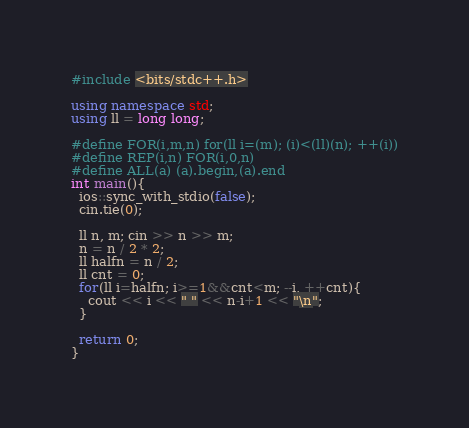Convert code to text. <code><loc_0><loc_0><loc_500><loc_500><_C++_>#include <bits/stdc++.h>

using namespace std;
using ll = long long;

#define FOR(i,m,n) for(ll i=(m); (i)<(ll)(n); ++(i))
#define REP(i,n) FOR(i,0,n)
#define ALL(a) (a).begin,(a).end
int main(){
  ios::sync_with_stdio(false);
  cin.tie(0);
  
  ll n, m; cin >> n >> m;
  n = n / 2 * 2;
  ll halfn = n / 2;
  ll cnt = 0;
  for(ll i=halfn; i>=1&&cnt<m; --i, ++cnt){
    cout << i << " " << n-i+1 << "\n";
  }
  
  return 0;
}</code> 